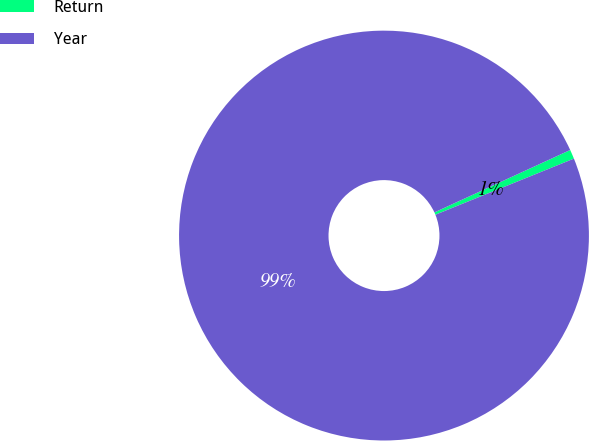<chart> <loc_0><loc_0><loc_500><loc_500><pie_chart><fcel>Return<fcel>Year<nl><fcel>0.73%<fcel>99.27%<nl></chart> 